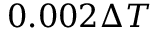<formula> <loc_0><loc_0><loc_500><loc_500>0 . 0 0 2 \Delta T</formula> 